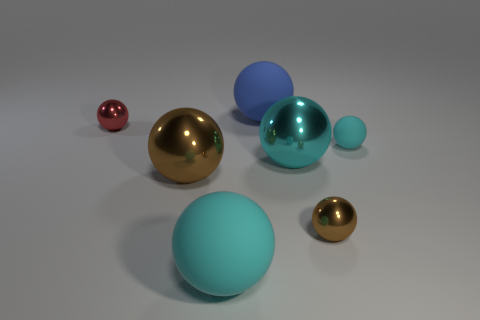Subtract all big brown balls. How many balls are left? 6 Subtract all blue blocks. How many cyan balls are left? 3 Add 2 large spheres. How many objects exist? 9 Subtract all red spheres. How many spheres are left? 6 Subtract 4 balls. How many balls are left? 3 Subtract all purple spheres. Subtract all green cylinders. How many spheres are left? 7 Add 5 big rubber balls. How many big rubber balls exist? 7 Subtract 0 purple cylinders. How many objects are left? 7 Subtract all tiny gray metallic cylinders. Subtract all cyan metallic spheres. How many objects are left? 6 Add 5 cyan things. How many cyan things are left? 8 